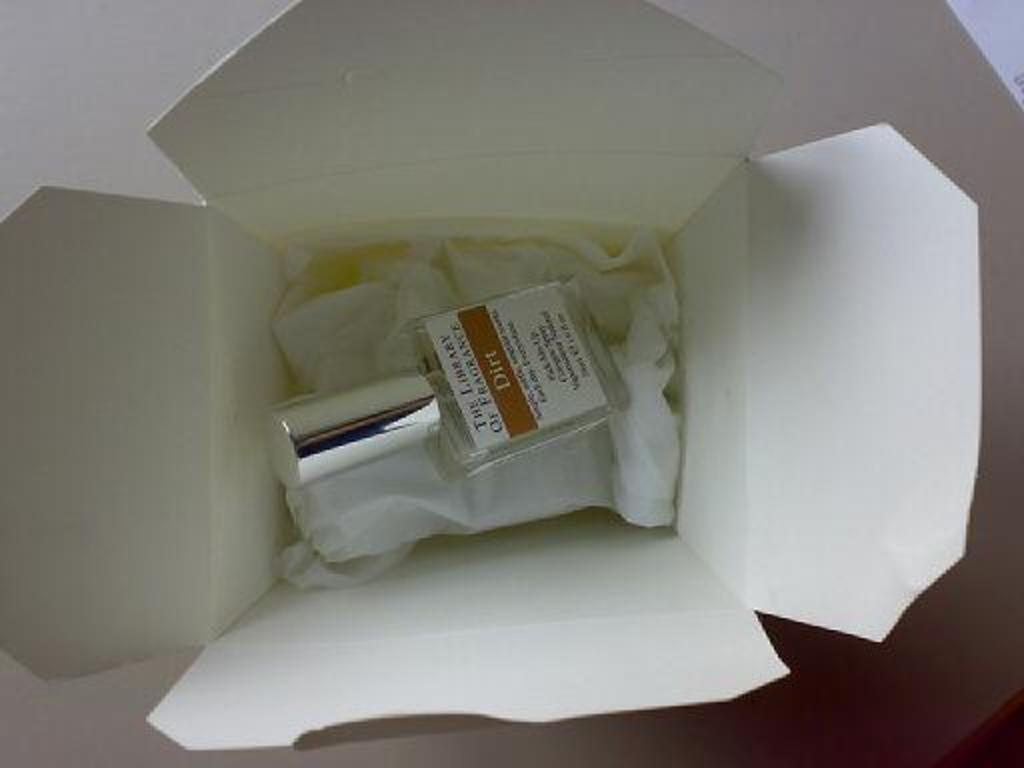<image>
Provide a brief description of the given image. A perfume bottle labeled the Library of Fragrance Dirt. 